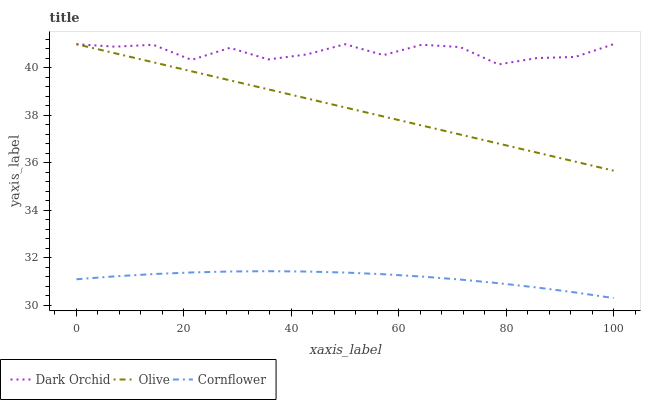Does Dark Orchid have the minimum area under the curve?
Answer yes or no. No. Does Cornflower have the maximum area under the curve?
Answer yes or no. No. Is Cornflower the smoothest?
Answer yes or no. No. Is Cornflower the roughest?
Answer yes or no. No. Does Dark Orchid have the lowest value?
Answer yes or no. No. Does Cornflower have the highest value?
Answer yes or no. No. Is Cornflower less than Dark Orchid?
Answer yes or no. Yes. Is Olive greater than Cornflower?
Answer yes or no. Yes. Does Cornflower intersect Dark Orchid?
Answer yes or no. No. 